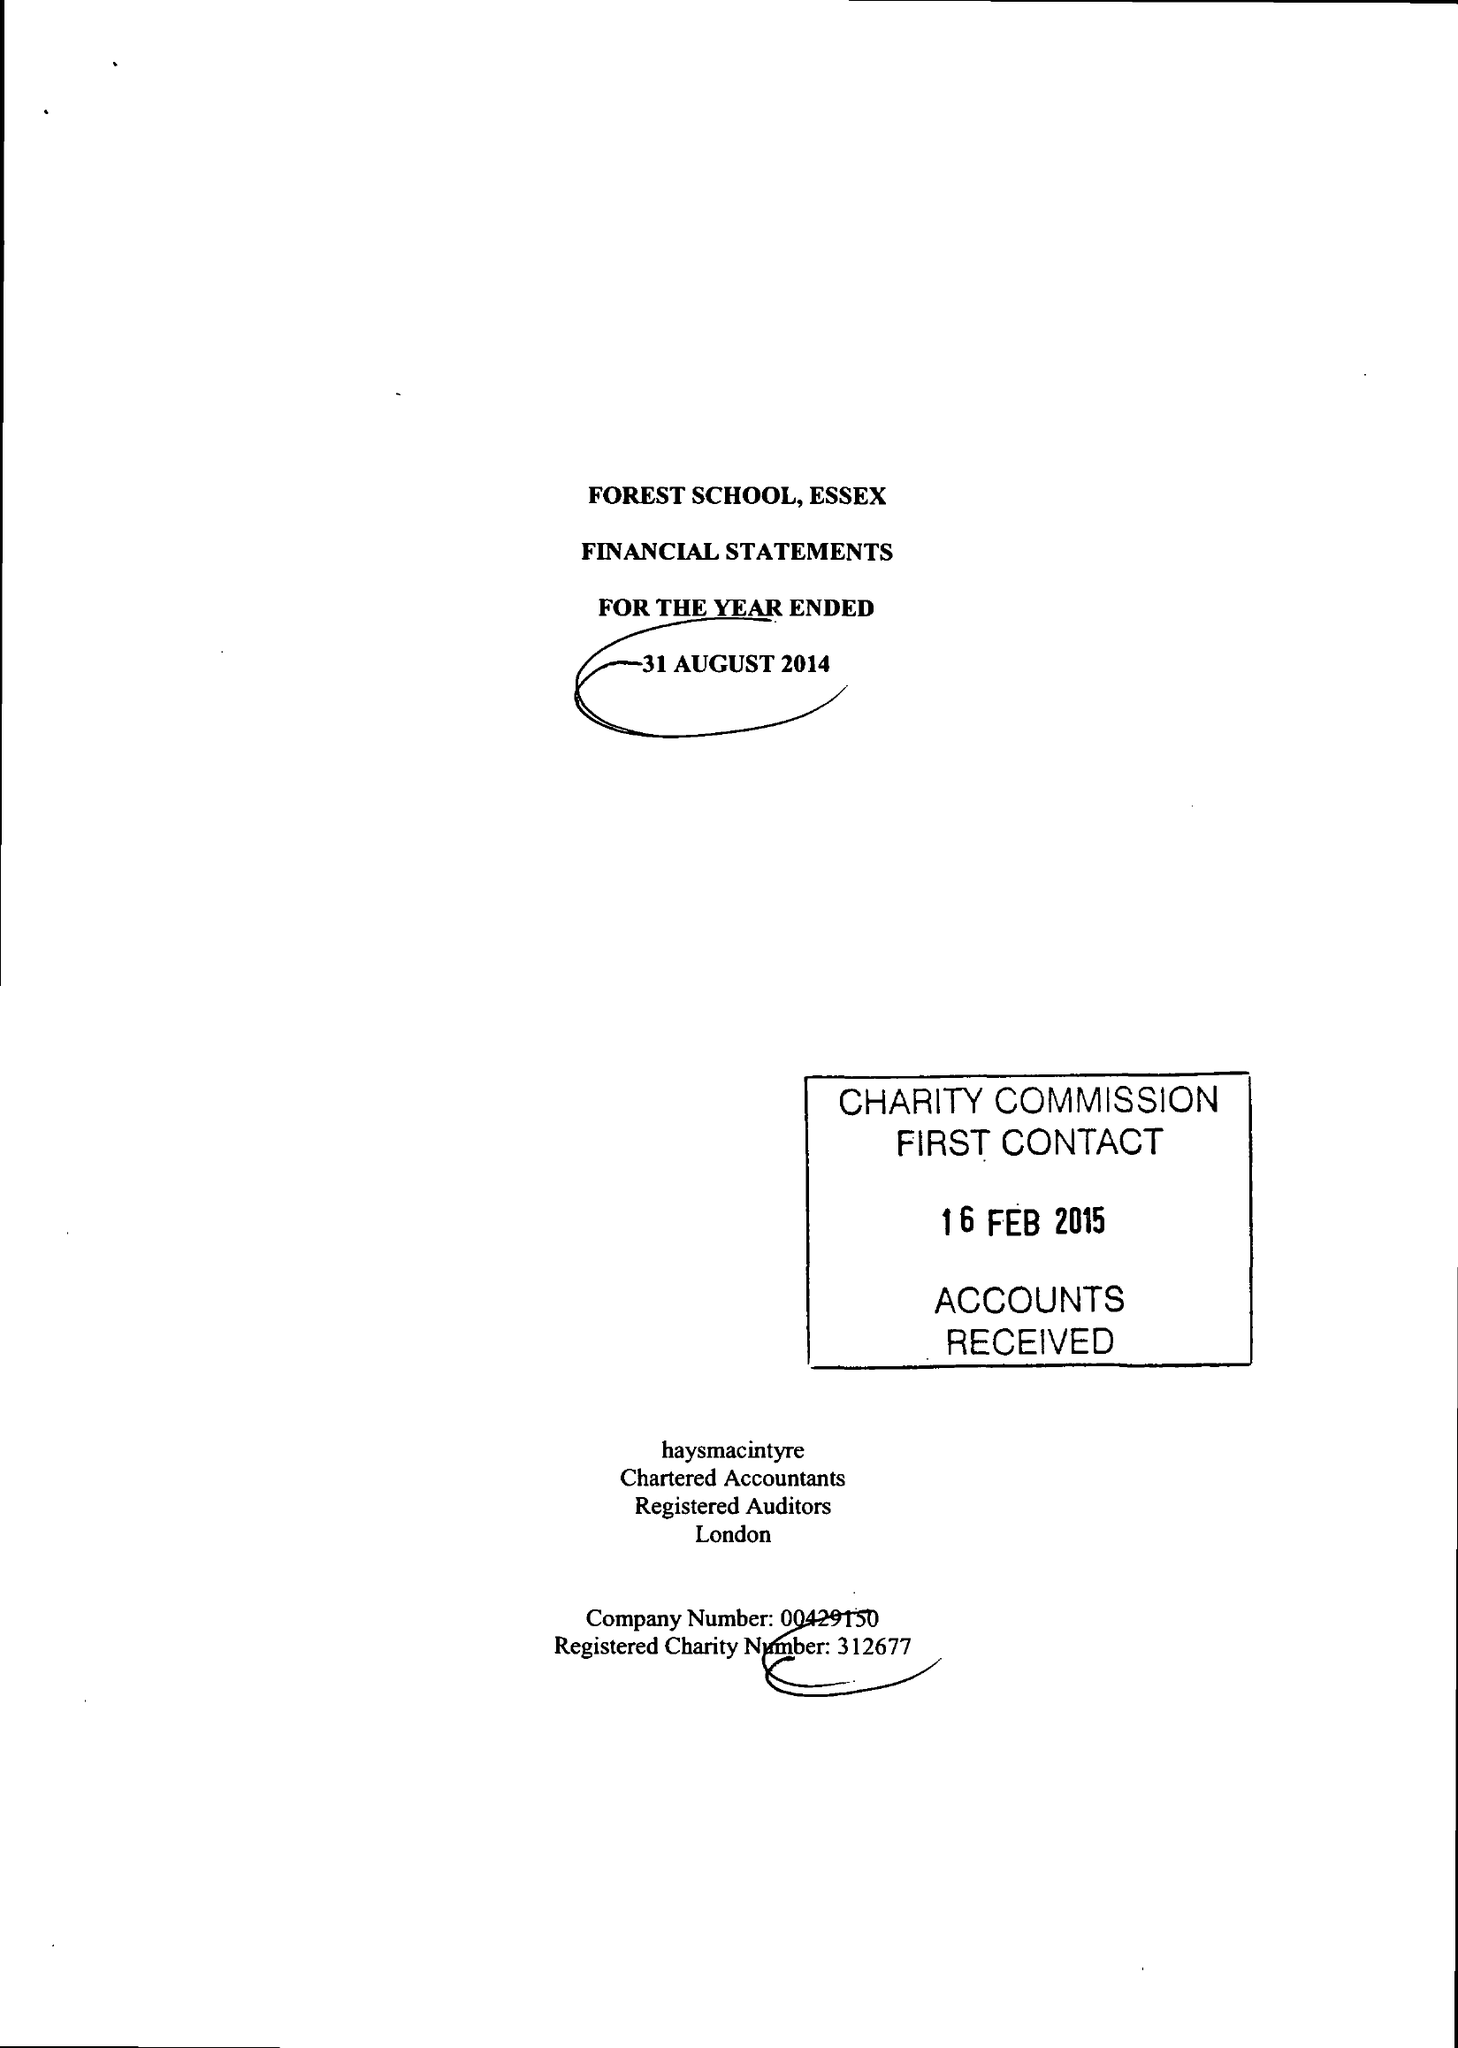What is the value for the address__postcode?
Answer the question using a single word or phrase. E17 3PY 